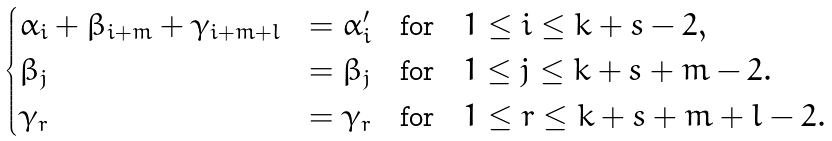<formula> <loc_0><loc_0><loc_500><loc_500>\begin{cases} \alpha _ { i } + \beta _ { i + m } + \gamma _ { i + m + l } & = \alpha _ { i } ^ { \prime } \quad \text {for} \quad 1 \leq i \leq k + s - 2 , \\ \beta _ { j } & = \beta _ { j } \quad \text {for} \quad 1 \leq j \leq k + s + m - 2 . \\ \gamma _ { r } & = \gamma _ { r } \quad \text {for} \quad 1 \leq r \leq k + s + m + l - 2 . \\ \end{cases}</formula> 